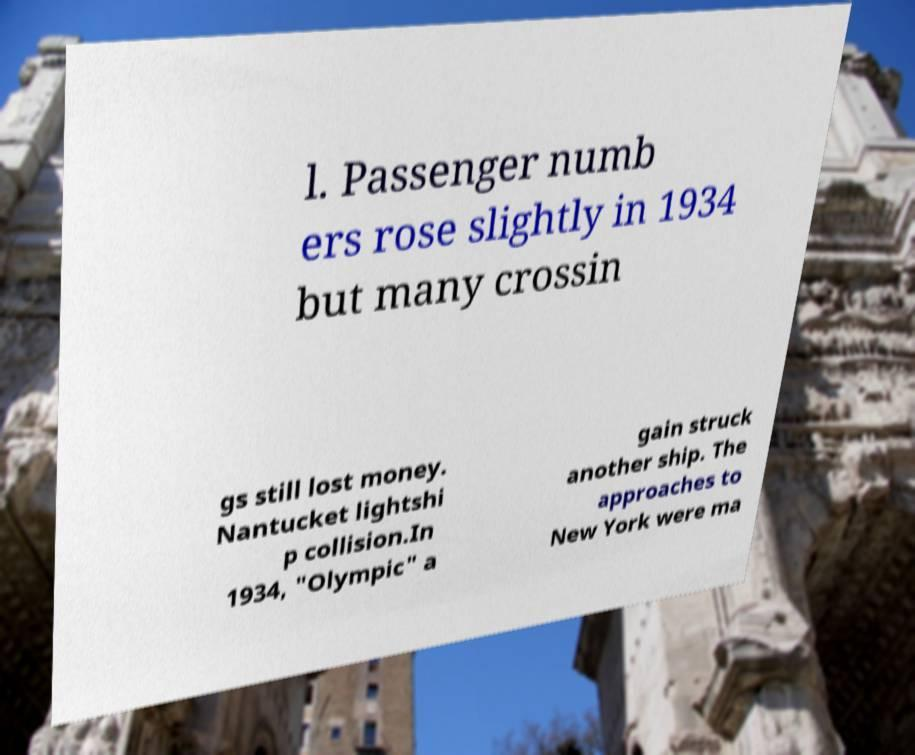Could you extract and type out the text from this image? l. Passenger numb ers rose slightly in 1934 but many crossin gs still lost money. Nantucket lightshi p collision.In 1934, "Olympic" a gain struck another ship. The approaches to New York were ma 